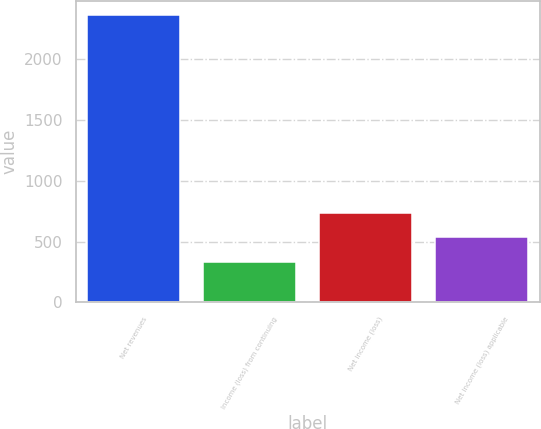Convert chart to OTSL. <chart><loc_0><loc_0><loc_500><loc_500><bar_chart><fcel>Net revenues<fcel>Income (loss) from continuing<fcel>Net income (loss)<fcel>Net income (loss) applicable<nl><fcel>2365<fcel>333<fcel>739.4<fcel>536.2<nl></chart> 